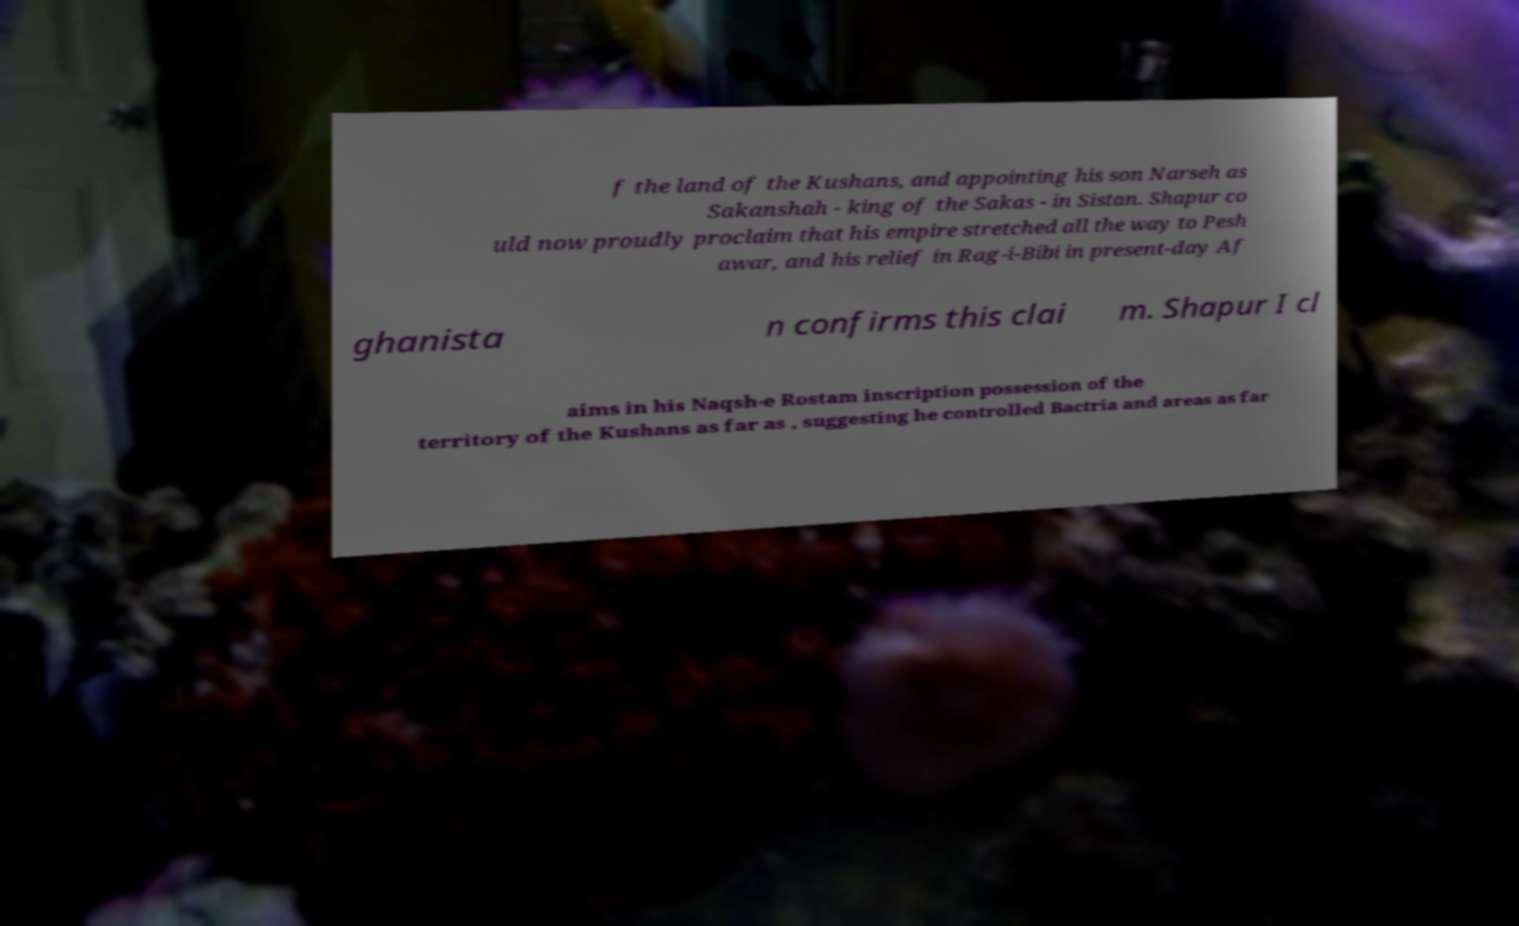For documentation purposes, I need the text within this image transcribed. Could you provide that? f the land of the Kushans, and appointing his son Narseh as Sakanshah - king of the Sakas - in Sistan. Shapur co uld now proudly proclaim that his empire stretched all the way to Pesh awar, and his relief in Rag-i-Bibi in present-day Af ghanista n confirms this clai m. Shapur I cl aims in his Naqsh-e Rostam inscription possession of the territory of the Kushans as far as , suggesting he controlled Bactria and areas as far 